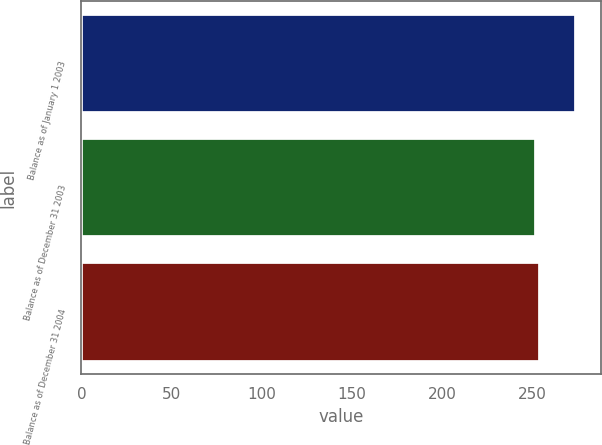Convert chart to OTSL. <chart><loc_0><loc_0><loc_500><loc_500><bar_chart><fcel>Balance as of January 1 2003<fcel>Balance as of December 31 2003<fcel>Balance as of December 31 2004<nl><fcel>274<fcel>252<fcel>254.2<nl></chart> 